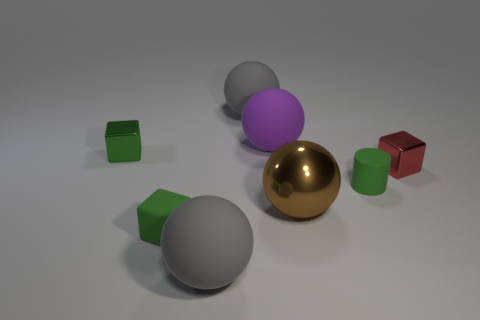How many green cubes must be subtracted to get 1 green cubes? 1 Subtract all gray balls. How many green cubes are left? 2 Subtract 2 spheres. How many spheres are left? 2 Subtract all big matte spheres. How many spheres are left? 1 Add 1 metallic cylinders. How many objects exist? 9 Subtract all green balls. Subtract all cyan cylinders. How many balls are left? 4 Subtract all blocks. How many objects are left? 5 Subtract all rubber objects. Subtract all rubber cylinders. How many objects are left? 2 Add 6 tiny green matte blocks. How many tiny green matte blocks are left? 7 Add 4 small cylinders. How many small cylinders exist? 5 